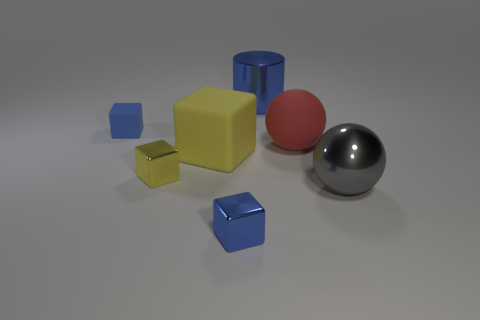Are there any big rubber spheres of the same color as the cylinder?
Ensure brevity in your answer.  No. There is a rubber ball that is behind the blue shiny cube; does it have the same size as the small matte object?
Provide a succinct answer. No. What is the color of the big rubber sphere?
Keep it short and to the point. Red. What is the color of the matte block that is to the right of the small blue object behind the large red thing?
Your answer should be very brief. Yellow. Is there a tiny red object that has the same material as the blue cylinder?
Provide a succinct answer. No. What material is the blue cube that is right of the matte thing that is to the left of the big yellow matte thing?
Make the answer very short. Metal. How many blue rubber objects have the same shape as the big gray metallic thing?
Offer a terse response. 0. What shape is the red object?
Offer a terse response. Sphere. Is the number of metallic things less than the number of large red rubber balls?
Offer a very short reply. No. Is there any other thing that is the same size as the yellow shiny object?
Offer a very short reply. Yes. 